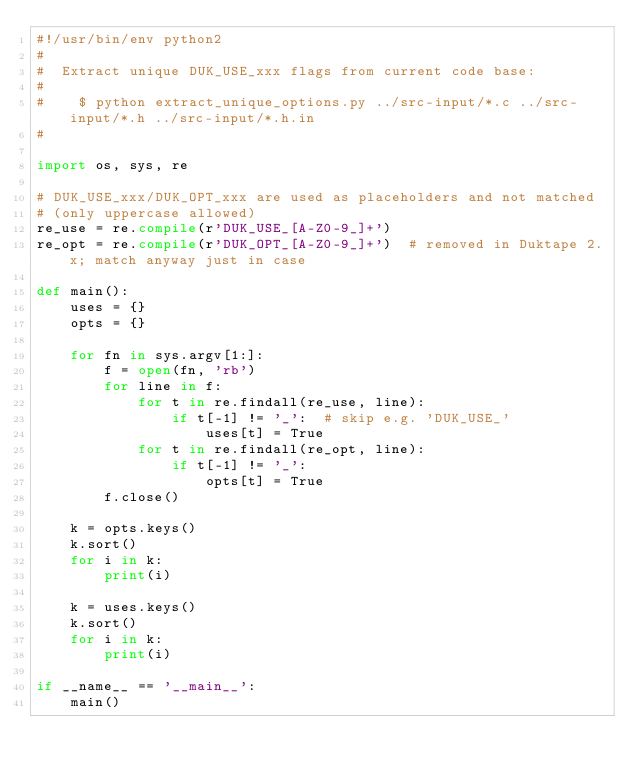<code> <loc_0><loc_0><loc_500><loc_500><_Python_>#!/usr/bin/env python2
#
#  Extract unique DUK_USE_xxx flags from current code base:
#
#    $ python extract_unique_options.py ../src-input/*.c ../src-input/*.h ../src-input/*.h.in
#

import os, sys, re

# DUK_USE_xxx/DUK_OPT_xxx are used as placeholders and not matched
# (only uppercase allowed)
re_use = re.compile(r'DUK_USE_[A-Z0-9_]+')
re_opt = re.compile(r'DUK_OPT_[A-Z0-9_]+')  # removed in Duktape 2.x; match anyway just in case

def main():
    uses = {}
    opts = {}

    for fn in sys.argv[1:]:
        f = open(fn, 'rb')
        for line in f:
            for t in re.findall(re_use, line):
                if t[-1] != '_':  # skip e.g. 'DUK_USE_'
                    uses[t] = True
            for t in re.findall(re_opt, line):
                if t[-1] != '_':
                    opts[t] = True
        f.close()

    k = opts.keys()
    k.sort()
    for i in k:
        print(i)

    k = uses.keys()
    k.sort()
    for i in k:
        print(i)

if __name__ == '__main__':
    main()
</code> 